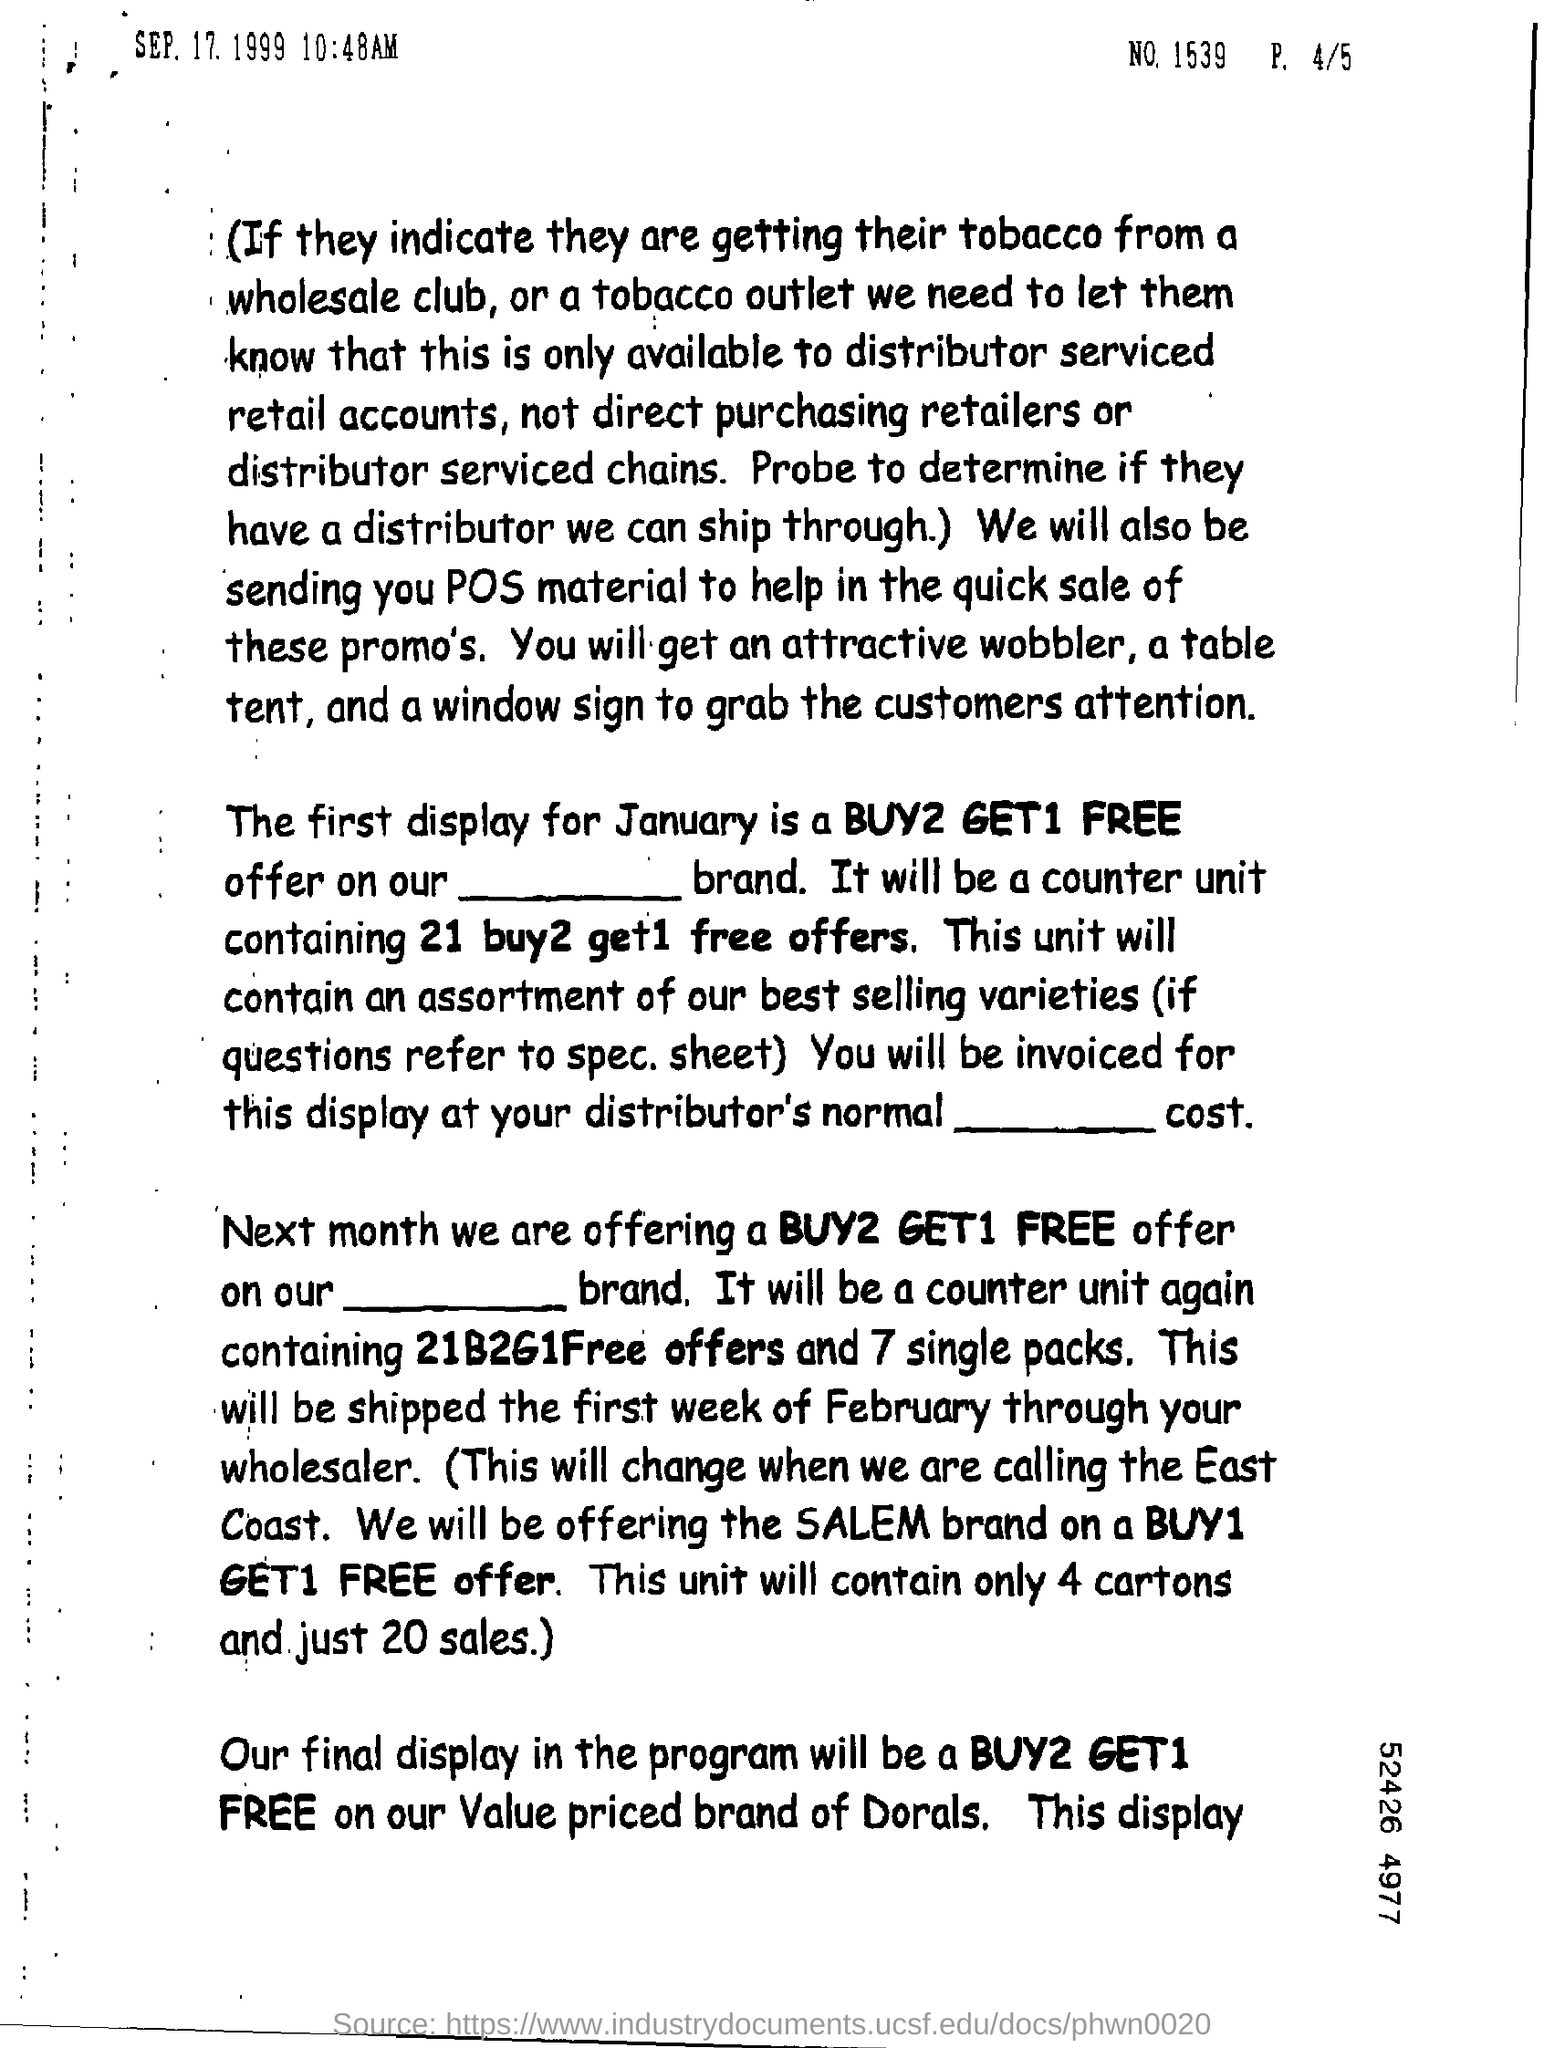What will be the final display in the program?
Your response must be concise. BUY2 GET1 FREE. 